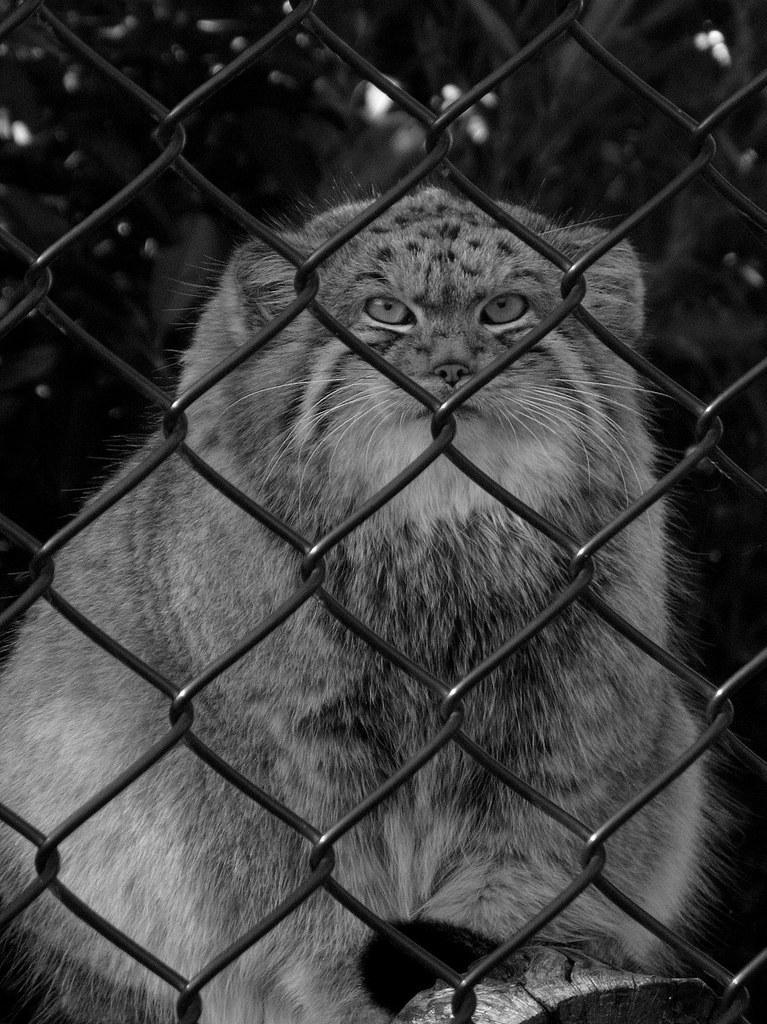Could you give a brief overview of what you see in this image? It is a black and white image, there is a mesh and behind the mesh there's a cat. 